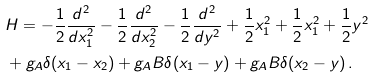<formula> <loc_0><loc_0><loc_500><loc_500>& H = - \frac { 1 } { 2 } \frac { d ^ { 2 } } { d x _ { 1 } ^ { 2 } } - \frac { 1 } { 2 } \frac { d ^ { 2 } } { d x _ { 2 } ^ { 2 } } - \frac { 1 } { 2 } \frac { d ^ { 2 } } { d y ^ { 2 } } + \frac { 1 } { 2 } x _ { 1 } ^ { 2 } + \frac { 1 } { 2 } x _ { 1 } ^ { 2 } + \frac { 1 } { 2 } y ^ { 2 } \\ & + g _ { A } \delta ( x _ { 1 } - x _ { 2 } ) + g _ { A } B \delta ( x _ { 1 } - y ) + g _ { A } B \delta ( x _ { 2 } - y ) \, .</formula> 